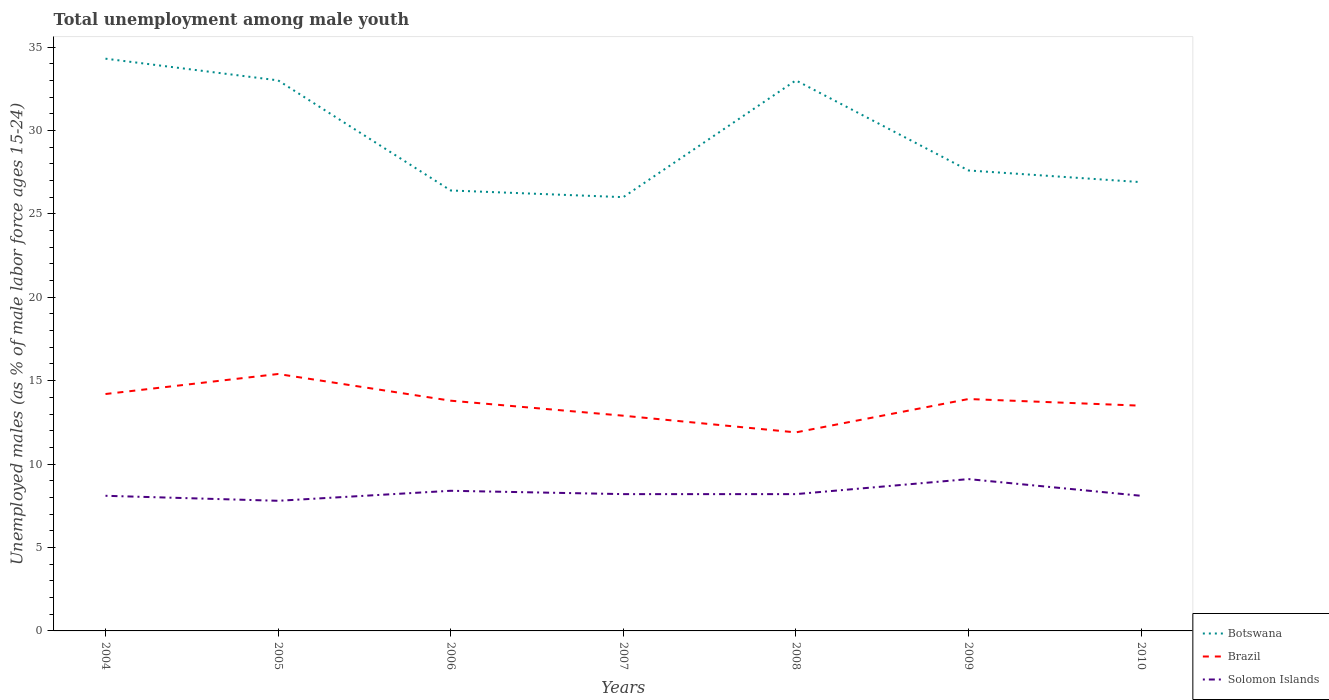Does the line corresponding to Solomon Islands intersect with the line corresponding to Botswana?
Your answer should be very brief. No. Is the number of lines equal to the number of legend labels?
Keep it short and to the point. Yes. Across all years, what is the maximum percentage of unemployed males in in Brazil?
Give a very brief answer. 11.9. In which year was the percentage of unemployed males in in Solomon Islands maximum?
Offer a terse response. 2005. What is the total percentage of unemployed males in in Solomon Islands in the graph?
Provide a short and direct response. -0.3. What is the difference between the highest and the second highest percentage of unemployed males in in Solomon Islands?
Your response must be concise. 1.3. What is the difference between the highest and the lowest percentage of unemployed males in in Solomon Islands?
Your answer should be compact. 2. Is the percentage of unemployed males in in Solomon Islands strictly greater than the percentage of unemployed males in in Botswana over the years?
Provide a short and direct response. Yes. How many lines are there?
Your response must be concise. 3. How many years are there in the graph?
Your answer should be very brief. 7. What is the difference between two consecutive major ticks on the Y-axis?
Keep it short and to the point. 5. Does the graph contain any zero values?
Offer a very short reply. No. Does the graph contain grids?
Keep it short and to the point. No. Where does the legend appear in the graph?
Your answer should be compact. Bottom right. What is the title of the graph?
Your response must be concise. Total unemployment among male youth. Does "Latin America(all income levels)" appear as one of the legend labels in the graph?
Your answer should be very brief. No. What is the label or title of the Y-axis?
Your answer should be compact. Unemployed males (as % of male labor force ages 15-24). What is the Unemployed males (as % of male labor force ages 15-24) of Botswana in 2004?
Ensure brevity in your answer.  34.3. What is the Unemployed males (as % of male labor force ages 15-24) of Brazil in 2004?
Offer a terse response. 14.2. What is the Unemployed males (as % of male labor force ages 15-24) in Solomon Islands in 2004?
Ensure brevity in your answer.  8.1. What is the Unemployed males (as % of male labor force ages 15-24) of Botswana in 2005?
Provide a short and direct response. 33. What is the Unemployed males (as % of male labor force ages 15-24) in Brazil in 2005?
Your answer should be compact. 15.4. What is the Unemployed males (as % of male labor force ages 15-24) in Solomon Islands in 2005?
Give a very brief answer. 7.8. What is the Unemployed males (as % of male labor force ages 15-24) of Botswana in 2006?
Your response must be concise. 26.4. What is the Unemployed males (as % of male labor force ages 15-24) of Brazil in 2006?
Provide a short and direct response. 13.8. What is the Unemployed males (as % of male labor force ages 15-24) of Solomon Islands in 2006?
Offer a very short reply. 8.4. What is the Unemployed males (as % of male labor force ages 15-24) in Brazil in 2007?
Give a very brief answer. 12.9. What is the Unemployed males (as % of male labor force ages 15-24) of Solomon Islands in 2007?
Your answer should be very brief. 8.2. What is the Unemployed males (as % of male labor force ages 15-24) in Brazil in 2008?
Your answer should be compact. 11.9. What is the Unemployed males (as % of male labor force ages 15-24) in Solomon Islands in 2008?
Your answer should be very brief. 8.2. What is the Unemployed males (as % of male labor force ages 15-24) in Botswana in 2009?
Offer a very short reply. 27.6. What is the Unemployed males (as % of male labor force ages 15-24) of Brazil in 2009?
Your answer should be compact. 13.9. What is the Unemployed males (as % of male labor force ages 15-24) of Solomon Islands in 2009?
Ensure brevity in your answer.  9.1. What is the Unemployed males (as % of male labor force ages 15-24) of Botswana in 2010?
Give a very brief answer. 26.9. What is the Unemployed males (as % of male labor force ages 15-24) in Solomon Islands in 2010?
Your response must be concise. 8.1. Across all years, what is the maximum Unemployed males (as % of male labor force ages 15-24) of Botswana?
Your answer should be compact. 34.3. Across all years, what is the maximum Unemployed males (as % of male labor force ages 15-24) in Brazil?
Keep it short and to the point. 15.4. Across all years, what is the maximum Unemployed males (as % of male labor force ages 15-24) in Solomon Islands?
Give a very brief answer. 9.1. Across all years, what is the minimum Unemployed males (as % of male labor force ages 15-24) of Brazil?
Ensure brevity in your answer.  11.9. Across all years, what is the minimum Unemployed males (as % of male labor force ages 15-24) in Solomon Islands?
Your response must be concise. 7.8. What is the total Unemployed males (as % of male labor force ages 15-24) of Botswana in the graph?
Offer a very short reply. 207.2. What is the total Unemployed males (as % of male labor force ages 15-24) of Brazil in the graph?
Provide a succinct answer. 95.6. What is the total Unemployed males (as % of male labor force ages 15-24) of Solomon Islands in the graph?
Provide a succinct answer. 57.9. What is the difference between the Unemployed males (as % of male labor force ages 15-24) of Brazil in 2004 and that in 2005?
Ensure brevity in your answer.  -1.2. What is the difference between the Unemployed males (as % of male labor force ages 15-24) of Solomon Islands in 2004 and that in 2005?
Your answer should be compact. 0.3. What is the difference between the Unemployed males (as % of male labor force ages 15-24) of Botswana in 2004 and that in 2006?
Offer a terse response. 7.9. What is the difference between the Unemployed males (as % of male labor force ages 15-24) in Solomon Islands in 2004 and that in 2006?
Your answer should be very brief. -0.3. What is the difference between the Unemployed males (as % of male labor force ages 15-24) of Brazil in 2004 and that in 2007?
Your answer should be compact. 1.3. What is the difference between the Unemployed males (as % of male labor force ages 15-24) of Solomon Islands in 2004 and that in 2007?
Provide a short and direct response. -0.1. What is the difference between the Unemployed males (as % of male labor force ages 15-24) in Brazil in 2004 and that in 2008?
Provide a succinct answer. 2.3. What is the difference between the Unemployed males (as % of male labor force ages 15-24) of Solomon Islands in 2004 and that in 2008?
Give a very brief answer. -0.1. What is the difference between the Unemployed males (as % of male labor force ages 15-24) in Botswana in 2004 and that in 2009?
Offer a very short reply. 6.7. What is the difference between the Unemployed males (as % of male labor force ages 15-24) in Brazil in 2004 and that in 2009?
Provide a succinct answer. 0.3. What is the difference between the Unemployed males (as % of male labor force ages 15-24) in Solomon Islands in 2004 and that in 2010?
Make the answer very short. 0. What is the difference between the Unemployed males (as % of male labor force ages 15-24) of Brazil in 2005 and that in 2006?
Provide a succinct answer. 1.6. What is the difference between the Unemployed males (as % of male labor force ages 15-24) of Solomon Islands in 2005 and that in 2006?
Your response must be concise. -0.6. What is the difference between the Unemployed males (as % of male labor force ages 15-24) of Botswana in 2005 and that in 2007?
Offer a very short reply. 7. What is the difference between the Unemployed males (as % of male labor force ages 15-24) in Brazil in 2005 and that in 2008?
Make the answer very short. 3.5. What is the difference between the Unemployed males (as % of male labor force ages 15-24) in Solomon Islands in 2005 and that in 2008?
Give a very brief answer. -0.4. What is the difference between the Unemployed males (as % of male labor force ages 15-24) of Botswana in 2005 and that in 2009?
Your answer should be very brief. 5.4. What is the difference between the Unemployed males (as % of male labor force ages 15-24) of Brazil in 2005 and that in 2009?
Offer a terse response. 1.5. What is the difference between the Unemployed males (as % of male labor force ages 15-24) of Brazil in 2005 and that in 2010?
Your answer should be very brief. 1.9. What is the difference between the Unemployed males (as % of male labor force ages 15-24) in Botswana in 2006 and that in 2007?
Make the answer very short. 0.4. What is the difference between the Unemployed males (as % of male labor force ages 15-24) in Botswana in 2006 and that in 2008?
Your response must be concise. -6.6. What is the difference between the Unemployed males (as % of male labor force ages 15-24) of Brazil in 2006 and that in 2008?
Make the answer very short. 1.9. What is the difference between the Unemployed males (as % of male labor force ages 15-24) in Solomon Islands in 2006 and that in 2008?
Offer a terse response. 0.2. What is the difference between the Unemployed males (as % of male labor force ages 15-24) of Botswana in 2006 and that in 2009?
Keep it short and to the point. -1.2. What is the difference between the Unemployed males (as % of male labor force ages 15-24) of Solomon Islands in 2006 and that in 2009?
Ensure brevity in your answer.  -0.7. What is the difference between the Unemployed males (as % of male labor force ages 15-24) of Botswana in 2006 and that in 2010?
Provide a succinct answer. -0.5. What is the difference between the Unemployed males (as % of male labor force ages 15-24) in Brazil in 2006 and that in 2010?
Provide a succinct answer. 0.3. What is the difference between the Unemployed males (as % of male labor force ages 15-24) in Botswana in 2007 and that in 2008?
Your answer should be very brief. -7. What is the difference between the Unemployed males (as % of male labor force ages 15-24) in Solomon Islands in 2007 and that in 2008?
Your answer should be compact. 0. What is the difference between the Unemployed males (as % of male labor force ages 15-24) of Botswana in 2007 and that in 2009?
Your answer should be compact. -1.6. What is the difference between the Unemployed males (as % of male labor force ages 15-24) in Solomon Islands in 2007 and that in 2009?
Provide a succinct answer. -0.9. What is the difference between the Unemployed males (as % of male labor force ages 15-24) in Brazil in 2007 and that in 2010?
Your answer should be compact. -0.6. What is the difference between the Unemployed males (as % of male labor force ages 15-24) of Solomon Islands in 2007 and that in 2010?
Provide a short and direct response. 0.1. What is the difference between the Unemployed males (as % of male labor force ages 15-24) of Solomon Islands in 2008 and that in 2009?
Offer a very short reply. -0.9. What is the difference between the Unemployed males (as % of male labor force ages 15-24) of Botswana in 2008 and that in 2010?
Offer a terse response. 6.1. What is the difference between the Unemployed males (as % of male labor force ages 15-24) of Brazil in 2008 and that in 2010?
Ensure brevity in your answer.  -1.6. What is the difference between the Unemployed males (as % of male labor force ages 15-24) in Brazil in 2009 and that in 2010?
Provide a short and direct response. 0.4. What is the difference between the Unemployed males (as % of male labor force ages 15-24) in Solomon Islands in 2009 and that in 2010?
Your response must be concise. 1. What is the difference between the Unemployed males (as % of male labor force ages 15-24) in Botswana in 2004 and the Unemployed males (as % of male labor force ages 15-24) in Brazil in 2005?
Your answer should be compact. 18.9. What is the difference between the Unemployed males (as % of male labor force ages 15-24) of Botswana in 2004 and the Unemployed males (as % of male labor force ages 15-24) of Solomon Islands in 2005?
Your answer should be very brief. 26.5. What is the difference between the Unemployed males (as % of male labor force ages 15-24) of Botswana in 2004 and the Unemployed males (as % of male labor force ages 15-24) of Brazil in 2006?
Your answer should be very brief. 20.5. What is the difference between the Unemployed males (as % of male labor force ages 15-24) in Botswana in 2004 and the Unemployed males (as % of male labor force ages 15-24) in Solomon Islands in 2006?
Provide a short and direct response. 25.9. What is the difference between the Unemployed males (as % of male labor force ages 15-24) in Botswana in 2004 and the Unemployed males (as % of male labor force ages 15-24) in Brazil in 2007?
Ensure brevity in your answer.  21.4. What is the difference between the Unemployed males (as % of male labor force ages 15-24) of Botswana in 2004 and the Unemployed males (as % of male labor force ages 15-24) of Solomon Islands in 2007?
Ensure brevity in your answer.  26.1. What is the difference between the Unemployed males (as % of male labor force ages 15-24) in Botswana in 2004 and the Unemployed males (as % of male labor force ages 15-24) in Brazil in 2008?
Your answer should be compact. 22.4. What is the difference between the Unemployed males (as % of male labor force ages 15-24) in Botswana in 2004 and the Unemployed males (as % of male labor force ages 15-24) in Solomon Islands in 2008?
Your answer should be very brief. 26.1. What is the difference between the Unemployed males (as % of male labor force ages 15-24) of Botswana in 2004 and the Unemployed males (as % of male labor force ages 15-24) of Brazil in 2009?
Make the answer very short. 20.4. What is the difference between the Unemployed males (as % of male labor force ages 15-24) in Botswana in 2004 and the Unemployed males (as % of male labor force ages 15-24) in Solomon Islands in 2009?
Offer a terse response. 25.2. What is the difference between the Unemployed males (as % of male labor force ages 15-24) of Brazil in 2004 and the Unemployed males (as % of male labor force ages 15-24) of Solomon Islands in 2009?
Ensure brevity in your answer.  5.1. What is the difference between the Unemployed males (as % of male labor force ages 15-24) of Botswana in 2004 and the Unemployed males (as % of male labor force ages 15-24) of Brazil in 2010?
Make the answer very short. 20.8. What is the difference between the Unemployed males (as % of male labor force ages 15-24) of Botswana in 2004 and the Unemployed males (as % of male labor force ages 15-24) of Solomon Islands in 2010?
Provide a short and direct response. 26.2. What is the difference between the Unemployed males (as % of male labor force ages 15-24) in Brazil in 2004 and the Unemployed males (as % of male labor force ages 15-24) in Solomon Islands in 2010?
Give a very brief answer. 6.1. What is the difference between the Unemployed males (as % of male labor force ages 15-24) in Botswana in 2005 and the Unemployed males (as % of male labor force ages 15-24) in Brazil in 2006?
Make the answer very short. 19.2. What is the difference between the Unemployed males (as % of male labor force ages 15-24) of Botswana in 2005 and the Unemployed males (as % of male labor force ages 15-24) of Solomon Islands in 2006?
Keep it short and to the point. 24.6. What is the difference between the Unemployed males (as % of male labor force ages 15-24) in Botswana in 2005 and the Unemployed males (as % of male labor force ages 15-24) in Brazil in 2007?
Provide a short and direct response. 20.1. What is the difference between the Unemployed males (as % of male labor force ages 15-24) in Botswana in 2005 and the Unemployed males (as % of male labor force ages 15-24) in Solomon Islands in 2007?
Provide a succinct answer. 24.8. What is the difference between the Unemployed males (as % of male labor force ages 15-24) of Brazil in 2005 and the Unemployed males (as % of male labor force ages 15-24) of Solomon Islands in 2007?
Offer a terse response. 7.2. What is the difference between the Unemployed males (as % of male labor force ages 15-24) in Botswana in 2005 and the Unemployed males (as % of male labor force ages 15-24) in Brazil in 2008?
Keep it short and to the point. 21.1. What is the difference between the Unemployed males (as % of male labor force ages 15-24) of Botswana in 2005 and the Unemployed males (as % of male labor force ages 15-24) of Solomon Islands in 2008?
Make the answer very short. 24.8. What is the difference between the Unemployed males (as % of male labor force ages 15-24) of Botswana in 2005 and the Unemployed males (as % of male labor force ages 15-24) of Brazil in 2009?
Your answer should be compact. 19.1. What is the difference between the Unemployed males (as % of male labor force ages 15-24) in Botswana in 2005 and the Unemployed males (as % of male labor force ages 15-24) in Solomon Islands in 2009?
Keep it short and to the point. 23.9. What is the difference between the Unemployed males (as % of male labor force ages 15-24) of Botswana in 2005 and the Unemployed males (as % of male labor force ages 15-24) of Brazil in 2010?
Your answer should be compact. 19.5. What is the difference between the Unemployed males (as % of male labor force ages 15-24) in Botswana in 2005 and the Unemployed males (as % of male labor force ages 15-24) in Solomon Islands in 2010?
Give a very brief answer. 24.9. What is the difference between the Unemployed males (as % of male labor force ages 15-24) of Botswana in 2006 and the Unemployed males (as % of male labor force ages 15-24) of Brazil in 2007?
Your response must be concise. 13.5. What is the difference between the Unemployed males (as % of male labor force ages 15-24) in Brazil in 2006 and the Unemployed males (as % of male labor force ages 15-24) in Solomon Islands in 2007?
Your response must be concise. 5.6. What is the difference between the Unemployed males (as % of male labor force ages 15-24) of Botswana in 2006 and the Unemployed males (as % of male labor force ages 15-24) of Brazil in 2008?
Offer a very short reply. 14.5. What is the difference between the Unemployed males (as % of male labor force ages 15-24) of Botswana in 2006 and the Unemployed males (as % of male labor force ages 15-24) of Solomon Islands in 2008?
Your answer should be very brief. 18.2. What is the difference between the Unemployed males (as % of male labor force ages 15-24) of Brazil in 2006 and the Unemployed males (as % of male labor force ages 15-24) of Solomon Islands in 2008?
Give a very brief answer. 5.6. What is the difference between the Unemployed males (as % of male labor force ages 15-24) of Botswana in 2006 and the Unemployed males (as % of male labor force ages 15-24) of Solomon Islands in 2009?
Offer a very short reply. 17.3. What is the difference between the Unemployed males (as % of male labor force ages 15-24) of Botswana in 2006 and the Unemployed males (as % of male labor force ages 15-24) of Solomon Islands in 2010?
Offer a terse response. 18.3. What is the difference between the Unemployed males (as % of male labor force ages 15-24) of Botswana in 2007 and the Unemployed males (as % of male labor force ages 15-24) of Brazil in 2008?
Offer a very short reply. 14.1. What is the difference between the Unemployed males (as % of male labor force ages 15-24) in Botswana in 2007 and the Unemployed males (as % of male labor force ages 15-24) in Solomon Islands in 2009?
Keep it short and to the point. 16.9. What is the difference between the Unemployed males (as % of male labor force ages 15-24) in Botswana in 2007 and the Unemployed males (as % of male labor force ages 15-24) in Solomon Islands in 2010?
Your answer should be very brief. 17.9. What is the difference between the Unemployed males (as % of male labor force ages 15-24) of Brazil in 2007 and the Unemployed males (as % of male labor force ages 15-24) of Solomon Islands in 2010?
Give a very brief answer. 4.8. What is the difference between the Unemployed males (as % of male labor force ages 15-24) of Botswana in 2008 and the Unemployed males (as % of male labor force ages 15-24) of Solomon Islands in 2009?
Give a very brief answer. 23.9. What is the difference between the Unemployed males (as % of male labor force ages 15-24) of Botswana in 2008 and the Unemployed males (as % of male labor force ages 15-24) of Brazil in 2010?
Make the answer very short. 19.5. What is the difference between the Unemployed males (as % of male labor force ages 15-24) in Botswana in 2008 and the Unemployed males (as % of male labor force ages 15-24) in Solomon Islands in 2010?
Your response must be concise. 24.9. What is the difference between the Unemployed males (as % of male labor force ages 15-24) of Brazil in 2008 and the Unemployed males (as % of male labor force ages 15-24) of Solomon Islands in 2010?
Your response must be concise. 3.8. What is the difference between the Unemployed males (as % of male labor force ages 15-24) in Botswana in 2009 and the Unemployed males (as % of male labor force ages 15-24) in Brazil in 2010?
Offer a very short reply. 14.1. What is the difference between the Unemployed males (as % of male labor force ages 15-24) of Botswana in 2009 and the Unemployed males (as % of male labor force ages 15-24) of Solomon Islands in 2010?
Your answer should be very brief. 19.5. What is the average Unemployed males (as % of male labor force ages 15-24) of Botswana per year?
Provide a short and direct response. 29.6. What is the average Unemployed males (as % of male labor force ages 15-24) of Brazil per year?
Your answer should be compact. 13.66. What is the average Unemployed males (as % of male labor force ages 15-24) of Solomon Islands per year?
Provide a succinct answer. 8.27. In the year 2004, what is the difference between the Unemployed males (as % of male labor force ages 15-24) of Botswana and Unemployed males (as % of male labor force ages 15-24) of Brazil?
Provide a succinct answer. 20.1. In the year 2004, what is the difference between the Unemployed males (as % of male labor force ages 15-24) of Botswana and Unemployed males (as % of male labor force ages 15-24) of Solomon Islands?
Offer a terse response. 26.2. In the year 2004, what is the difference between the Unemployed males (as % of male labor force ages 15-24) in Brazil and Unemployed males (as % of male labor force ages 15-24) in Solomon Islands?
Give a very brief answer. 6.1. In the year 2005, what is the difference between the Unemployed males (as % of male labor force ages 15-24) of Botswana and Unemployed males (as % of male labor force ages 15-24) of Solomon Islands?
Your answer should be very brief. 25.2. In the year 2005, what is the difference between the Unemployed males (as % of male labor force ages 15-24) of Brazil and Unemployed males (as % of male labor force ages 15-24) of Solomon Islands?
Give a very brief answer. 7.6. In the year 2006, what is the difference between the Unemployed males (as % of male labor force ages 15-24) in Brazil and Unemployed males (as % of male labor force ages 15-24) in Solomon Islands?
Ensure brevity in your answer.  5.4. In the year 2007, what is the difference between the Unemployed males (as % of male labor force ages 15-24) in Botswana and Unemployed males (as % of male labor force ages 15-24) in Solomon Islands?
Your response must be concise. 17.8. In the year 2007, what is the difference between the Unemployed males (as % of male labor force ages 15-24) of Brazil and Unemployed males (as % of male labor force ages 15-24) of Solomon Islands?
Give a very brief answer. 4.7. In the year 2008, what is the difference between the Unemployed males (as % of male labor force ages 15-24) of Botswana and Unemployed males (as % of male labor force ages 15-24) of Brazil?
Provide a succinct answer. 21.1. In the year 2008, what is the difference between the Unemployed males (as % of male labor force ages 15-24) of Botswana and Unemployed males (as % of male labor force ages 15-24) of Solomon Islands?
Keep it short and to the point. 24.8. In the year 2010, what is the difference between the Unemployed males (as % of male labor force ages 15-24) of Botswana and Unemployed males (as % of male labor force ages 15-24) of Brazil?
Make the answer very short. 13.4. In the year 2010, what is the difference between the Unemployed males (as % of male labor force ages 15-24) in Botswana and Unemployed males (as % of male labor force ages 15-24) in Solomon Islands?
Your answer should be very brief. 18.8. In the year 2010, what is the difference between the Unemployed males (as % of male labor force ages 15-24) in Brazil and Unemployed males (as % of male labor force ages 15-24) in Solomon Islands?
Offer a very short reply. 5.4. What is the ratio of the Unemployed males (as % of male labor force ages 15-24) of Botswana in 2004 to that in 2005?
Offer a very short reply. 1.04. What is the ratio of the Unemployed males (as % of male labor force ages 15-24) in Brazil in 2004 to that in 2005?
Offer a very short reply. 0.92. What is the ratio of the Unemployed males (as % of male labor force ages 15-24) of Solomon Islands in 2004 to that in 2005?
Offer a very short reply. 1.04. What is the ratio of the Unemployed males (as % of male labor force ages 15-24) in Botswana in 2004 to that in 2006?
Offer a very short reply. 1.3. What is the ratio of the Unemployed males (as % of male labor force ages 15-24) of Brazil in 2004 to that in 2006?
Provide a short and direct response. 1.03. What is the ratio of the Unemployed males (as % of male labor force ages 15-24) of Solomon Islands in 2004 to that in 2006?
Offer a terse response. 0.96. What is the ratio of the Unemployed males (as % of male labor force ages 15-24) in Botswana in 2004 to that in 2007?
Offer a terse response. 1.32. What is the ratio of the Unemployed males (as % of male labor force ages 15-24) in Brazil in 2004 to that in 2007?
Make the answer very short. 1.1. What is the ratio of the Unemployed males (as % of male labor force ages 15-24) of Botswana in 2004 to that in 2008?
Offer a very short reply. 1.04. What is the ratio of the Unemployed males (as % of male labor force ages 15-24) of Brazil in 2004 to that in 2008?
Your answer should be compact. 1.19. What is the ratio of the Unemployed males (as % of male labor force ages 15-24) of Solomon Islands in 2004 to that in 2008?
Give a very brief answer. 0.99. What is the ratio of the Unemployed males (as % of male labor force ages 15-24) of Botswana in 2004 to that in 2009?
Keep it short and to the point. 1.24. What is the ratio of the Unemployed males (as % of male labor force ages 15-24) in Brazil in 2004 to that in 2009?
Provide a short and direct response. 1.02. What is the ratio of the Unemployed males (as % of male labor force ages 15-24) in Solomon Islands in 2004 to that in 2009?
Your response must be concise. 0.89. What is the ratio of the Unemployed males (as % of male labor force ages 15-24) of Botswana in 2004 to that in 2010?
Keep it short and to the point. 1.28. What is the ratio of the Unemployed males (as % of male labor force ages 15-24) in Brazil in 2004 to that in 2010?
Provide a succinct answer. 1.05. What is the ratio of the Unemployed males (as % of male labor force ages 15-24) in Solomon Islands in 2004 to that in 2010?
Your answer should be compact. 1. What is the ratio of the Unemployed males (as % of male labor force ages 15-24) in Brazil in 2005 to that in 2006?
Offer a very short reply. 1.12. What is the ratio of the Unemployed males (as % of male labor force ages 15-24) of Solomon Islands in 2005 to that in 2006?
Offer a terse response. 0.93. What is the ratio of the Unemployed males (as % of male labor force ages 15-24) of Botswana in 2005 to that in 2007?
Offer a terse response. 1.27. What is the ratio of the Unemployed males (as % of male labor force ages 15-24) in Brazil in 2005 to that in 2007?
Give a very brief answer. 1.19. What is the ratio of the Unemployed males (as % of male labor force ages 15-24) in Solomon Islands in 2005 to that in 2007?
Your response must be concise. 0.95. What is the ratio of the Unemployed males (as % of male labor force ages 15-24) of Botswana in 2005 to that in 2008?
Offer a terse response. 1. What is the ratio of the Unemployed males (as % of male labor force ages 15-24) of Brazil in 2005 to that in 2008?
Your answer should be compact. 1.29. What is the ratio of the Unemployed males (as % of male labor force ages 15-24) of Solomon Islands in 2005 to that in 2008?
Keep it short and to the point. 0.95. What is the ratio of the Unemployed males (as % of male labor force ages 15-24) of Botswana in 2005 to that in 2009?
Your response must be concise. 1.2. What is the ratio of the Unemployed males (as % of male labor force ages 15-24) of Brazil in 2005 to that in 2009?
Your response must be concise. 1.11. What is the ratio of the Unemployed males (as % of male labor force ages 15-24) of Botswana in 2005 to that in 2010?
Ensure brevity in your answer.  1.23. What is the ratio of the Unemployed males (as % of male labor force ages 15-24) of Brazil in 2005 to that in 2010?
Ensure brevity in your answer.  1.14. What is the ratio of the Unemployed males (as % of male labor force ages 15-24) of Solomon Islands in 2005 to that in 2010?
Provide a succinct answer. 0.96. What is the ratio of the Unemployed males (as % of male labor force ages 15-24) in Botswana in 2006 to that in 2007?
Provide a succinct answer. 1.02. What is the ratio of the Unemployed males (as % of male labor force ages 15-24) in Brazil in 2006 to that in 2007?
Keep it short and to the point. 1.07. What is the ratio of the Unemployed males (as % of male labor force ages 15-24) of Solomon Islands in 2006 to that in 2007?
Give a very brief answer. 1.02. What is the ratio of the Unemployed males (as % of male labor force ages 15-24) in Brazil in 2006 to that in 2008?
Keep it short and to the point. 1.16. What is the ratio of the Unemployed males (as % of male labor force ages 15-24) in Solomon Islands in 2006 to that in 2008?
Give a very brief answer. 1.02. What is the ratio of the Unemployed males (as % of male labor force ages 15-24) in Botswana in 2006 to that in 2009?
Offer a very short reply. 0.96. What is the ratio of the Unemployed males (as % of male labor force ages 15-24) in Botswana in 2006 to that in 2010?
Ensure brevity in your answer.  0.98. What is the ratio of the Unemployed males (as % of male labor force ages 15-24) of Brazil in 2006 to that in 2010?
Keep it short and to the point. 1.02. What is the ratio of the Unemployed males (as % of male labor force ages 15-24) in Solomon Islands in 2006 to that in 2010?
Keep it short and to the point. 1.04. What is the ratio of the Unemployed males (as % of male labor force ages 15-24) in Botswana in 2007 to that in 2008?
Provide a short and direct response. 0.79. What is the ratio of the Unemployed males (as % of male labor force ages 15-24) of Brazil in 2007 to that in 2008?
Ensure brevity in your answer.  1.08. What is the ratio of the Unemployed males (as % of male labor force ages 15-24) of Solomon Islands in 2007 to that in 2008?
Your answer should be compact. 1. What is the ratio of the Unemployed males (as % of male labor force ages 15-24) of Botswana in 2007 to that in 2009?
Offer a very short reply. 0.94. What is the ratio of the Unemployed males (as % of male labor force ages 15-24) in Brazil in 2007 to that in 2009?
Keep it short and to the point. 0.93. What is the ratio of the Unemployed males (as % of male labor force ages 15-24) of Solomon Islands in 2007 to that in 2009?
Your response must be concise. 0.9. What is the ratio of the Unemployed males (as % of male labor force ages 15-24) of Botswana in 2007 to that in 2010?
Ensure brevity in your answer.  0.97. What is the ratio of the Unemployed males (as % of male labor force ages 15-24) of Brazil in 2007 to that in 2010?
Your answer should be compact. 0.96. What is the ratio of the Unemployed males (as % of male labor force ages 15-24) in Solomon Islands in 2007 to that in 2010?
Your answer should be very brief. 1.01. What is the ratio of the Unemployed males (as % of male labor force ages 15-24) of Botswana in 2008 to that in 2009?
Your answer should be very brief. 1.2. What is the ratio of the Unemployed males (as % of male labor force ages 15-24) of Brazil in 2008 to that in 2009?
Your answer should be compact. 0.86. What is the ratio of the Unemployed males (as % of male labor force ages 15-24) in Solomon Islands in 2008 to that in 2009?
Your response must be concise. 0.9. What is the ratio of the Unemployed males (as % of male labor force ages 15-24) of Botswana in 2008 to that in 2010?
Your response must be concise. 1.23. What is the ratio of the Unemployed males (as % of male labor force ages 15-24) of Brazil in 2008 to that in 2010?
Your answer should be very brief. 0.88. What is the ratio of the Unemployed males (as % of male labor force ages 15-24) in Solomon Islands in 2008 to that in 2010?
Give a very brief answer. 1.01. What is the ratio of the Unemployed males (as % of male labor force ages 15-24) in Brazil in 2009 to that in 2010?
Your answer should be very brief. 1.03. What is the ratio of the Unemployed males (as % of male labor force ages 15-24) in Solomon Islands in 2009 to that in 2010?
Make the answer very short. 1.12. What is the difference between the highest and the second highest Unemployed males (as % of male labor force ages 15-24) of Brazil?
Provide a succinct answer. 1.2. What is the difference between the highest and the second highest Unemployed males (as % of male labor force ages 15-24) in Solomon Islands?
Keep it short and to the point. 0.7. What is the difference between the highest and the lowest Unemployed males (as % of male labor force ages 15-24) of Botswana?
Provide a succinct answer. 8.3. What is the difference between the highest and the lowest Unemployed males (as % of male labor force ages 15-24) in Brazil?
Provide a succinct answer. 3.5. 